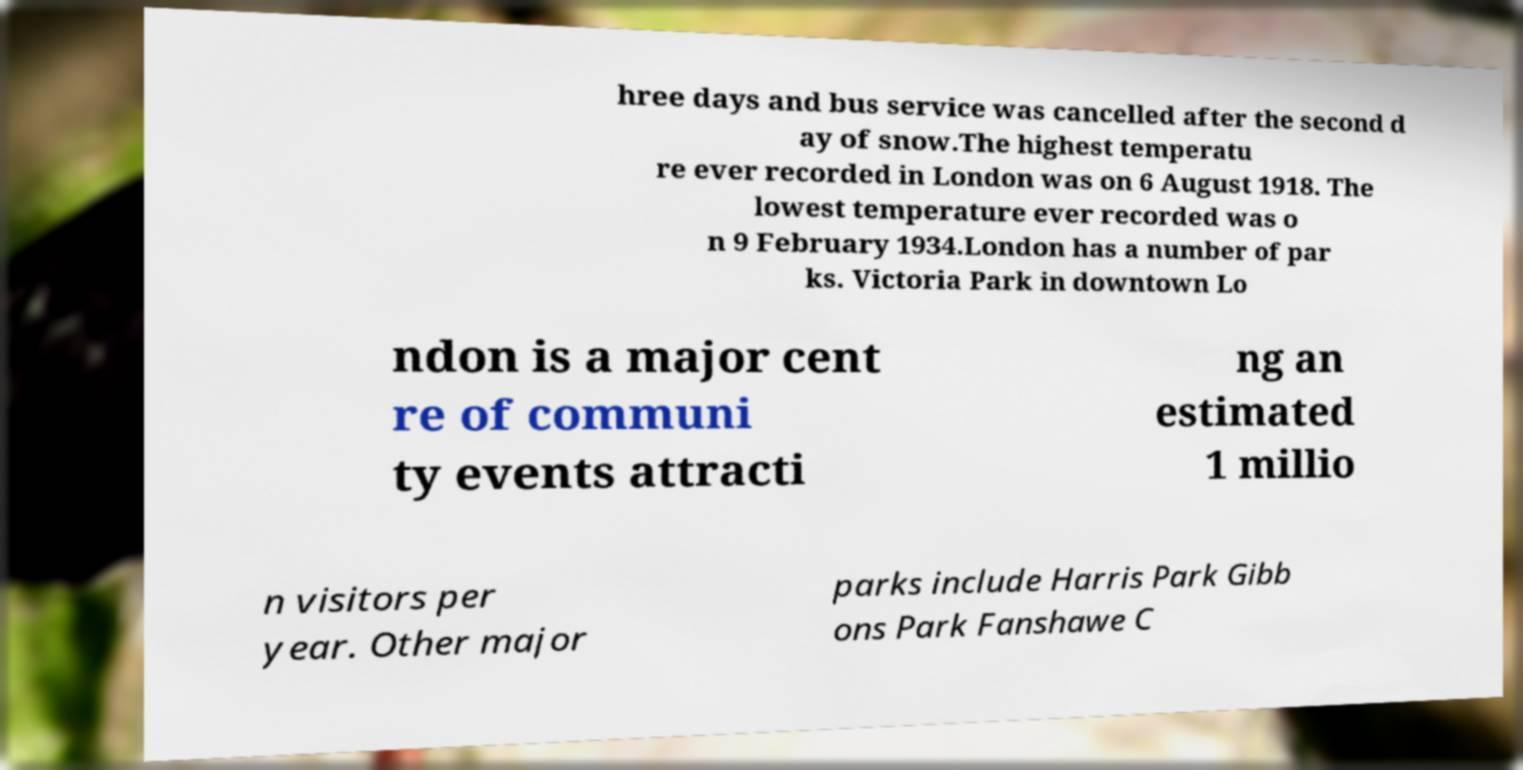Please identify and transcribe the text found in this image. hree days and bus service was cancelled after the second d ay of snow.The highest temperatu re ever recorded in London was on 6 August 1918. The lowest temperature ever recorded was o n 9 February 1934.London has a number of par ks. Victoria Park in downtown Lo ndon is a major cent re of communi ty events attracti ng an estimated 1 millio n visitors per year. Other major parks include Harris Park Gibb ons Park Fanshawe C 